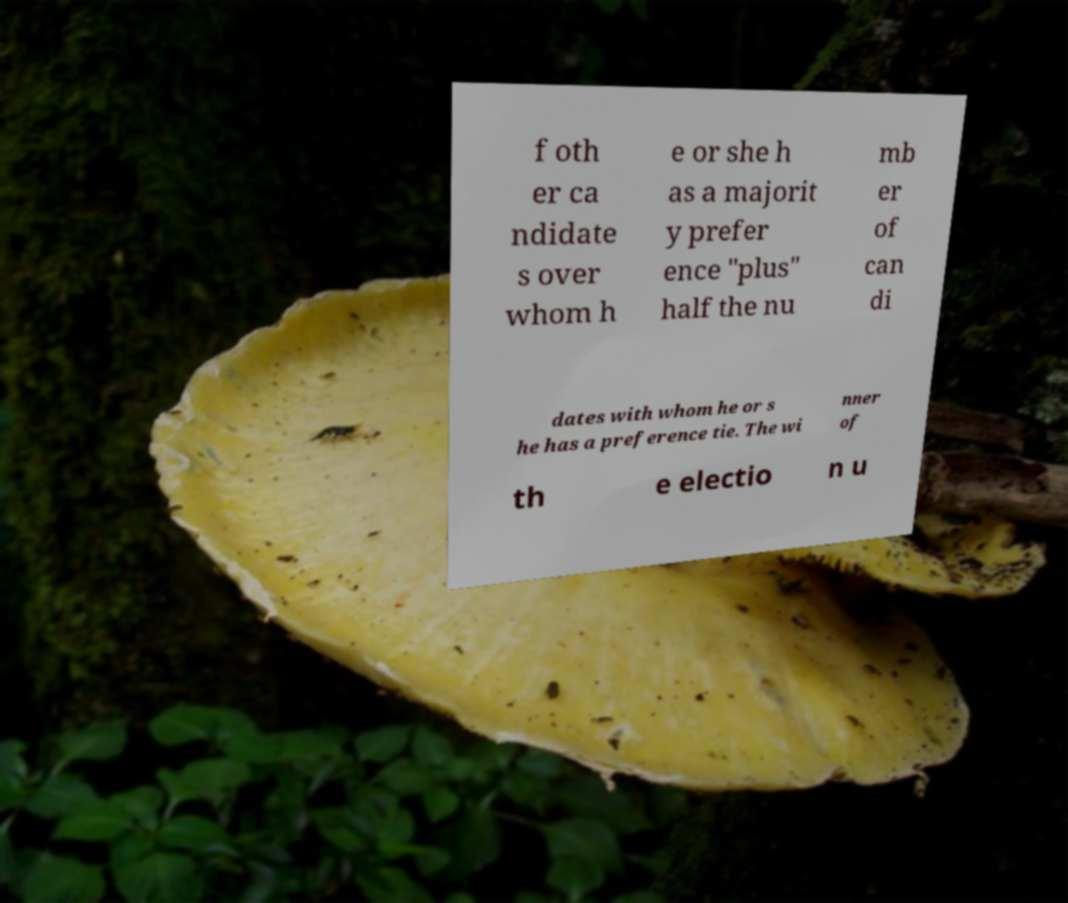Can you read and provide the text displayed in the image?This photo seems to have some interesting text. Can you extract and type it out for me? f oth er ca ndidate s over whom h e or she h as a majorit y prefer ence "plus" half the nu mb er of can di dates with whom he or s he has a preference tie. The wi nner of th e electio n u 